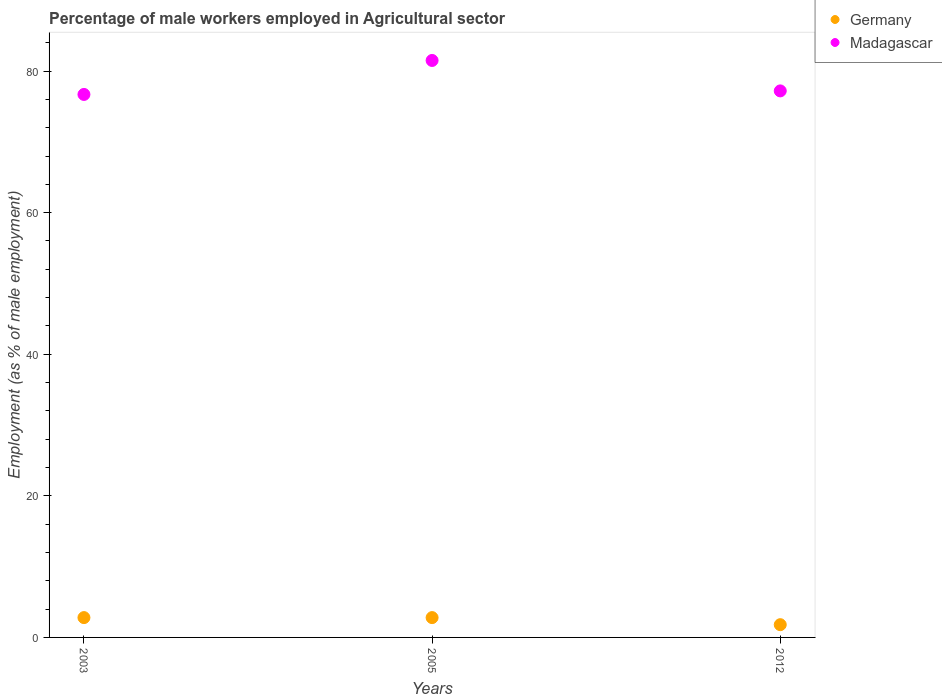How many different coloured dotlines are there?
Offer a terse response. 2. What is the percentage of male workers employed in Agricultural sector in Germany in 2005?
Offer a terse response. 2.8. Across all years, what is the maximum percentage of male workers employed in Agricultural sector in Madagascar?
Ensure brevity in your answer.  81.5. Across all years, what is the minimum percentage of male workers employed in Agricultural sector in Germany?
Offer a very short reply. 1.8. In which year was the percentage of male workers employed in Agricultural sector in Madagascar minimum?
Provide a short and direct response. 2003. What is the total percentage of male workers employed in Agricultural sector in Germany in the graph?
Provide a short and direct response. 7.4. What is the difference between the percentage of male workers employed in Agricultural sector in Germany in 2005 and that in 2012?
Ensure brevity in your answer.  1. What is the difference between the percentage of male workers employed in Agricultural sector in Germany in 2003 and the percentage of male workers employed in Agricultural sector in Madagascar in 2005?
Provide a succinct answer. -78.7. What is the average percentage of male workers employed in Agricultural sector in Germany per year?
Keep it short and to the point. 2.47. In the year 2003, what is the difference between the percentage of male workers employed in Agricultural sector in Germany and percentage of male workers employed in Agricultural sector in Madagascar?
Provide a short and direct response. -73.9. In how many years, is the percentage of male workers employed in Agricultural sector in Germany greater than 48 %?
Keep it short and to the point. 0. What is the ratio of the percentage of male workers employed in Agricultural sector in Germany in 2003 to that in 2012?
Ensure brevity in your answer.  1.56. What is the difference between the highest and the lowest percentage of male workers employed in Agricultural sector in Germany?
Give a very brief answer. 1. Does the percentage of male workers employed in Agricultural sector in Germany monotonically increase over the years?
Keep it short and to the point. No. Is the percentage of male workers employed in Agricultural sector in Madagascar strictly greater than the percentage of male workers employed in Agricultural sector in Germany over the years?
Offer a terse response. Yes. How many years are there in the graph?
Your response must be concise. 3. Does the graph contain any zero values?
Provide a short and direct response. No. Does the graph contain grids?
Give a very brief answer. No. Where does the legend appear in the graph?
Provide a succinct answer. Top right. How many legend labels are there?
Your answer should be compact. 2. How are the legend labels stacked?
Keep it short and to the point. Vertical. What is the title of the graph?
Provide a succinct answer. Percentage of male workers employed in Agricultural sector. What is the label or title of the X-axis?
Your response must be concise. Years. What is the label or title of the Y-axis?
Ensure brevity in your answer.  Employment (as % of male employment). What is the Employment (as % of male employment) of Germany in 2003?
Your response must be concise. 2.8. What is the Employment (as % of male employment) in Madagascar in 2003?
Your answer should be compact. 76.7. What is the Employment (as % of male employment) in Germany in 2005?
Keep it short and to the point. 2.8. What is the Employment (as % of male employment) of Madagascar in 2005?
Ensure brevity in your answer.  81.5. What is the Employment (as % of male employment) of Germany in 2012?
Make the answer very short. 1.8. What is the Employment (as % of male employment) of Madagascar in 2012?
Ensure brevity in your answer.  77.2. Across all years, what is the maximum Employment (as % of male employment) of Germany?
Keep it short and to the point. 2.8. Across all years, what is the maximum Employment (as % of male employment) of Madagascar?
Your answer should be very brief. 81.5. Across all years, what is the minimum Employment (as % of male employment) in Germany?
Your response must be concise. 1.8. Across all years, what is the minimum Employment (as % of male employment) in Madagascar?
Provide a short and direct response. 76.7. What is the total Employment (as % of male employment) in Germany in the graph?
Offer a very short reply. 7.4. What is the total Employment (as % of male employment) in Madagascar in the graph?
Your answer should be very brief. 235.4. What is the difference between the Employment (as % of male employment) of Germany in 2005 and that in 2012?
Offer a terse response. 1. What is the difference between the Employment (as % of male employment) in Germany in 2003 and the Employment (as % of male employment) in Madagascar in 2005?
Make the answer very short. -78.7. What is the difference between the Employment (as % of male employment) of Germany in 2003 and the Employment (as % of male employment) of Madagascar in 2012?
Your answer should be very brief. -74.4. What is the difference between the Employment (as % of male employment) in Germany in 2005 and the Employment (as % of male employment) in Madagascar in 2012?
Give a very brief answer. -74.4. What is the average Employment (as % of male employment) in Germany per year?
Offer a very short reply. 2.47. What is the average Employment (as % of male employment) in Madagascar per year?
Your response must be concise. 78.47. In the year 2003, what is the difference between the Employment (as % of male employment) of Germany and Employment (as % of male employment) of Madagascar?
Offer a very short reply. -73.9. In the year 2005, what is the difference between the Employment (as % of male employment) of Germany and Employment (as % of male employment) of Madagascar?
Your answer should be compact. -78.7. In the year 2012, what is the difference between the Employment (as % of male employment) in Germany and Employment (as % of male employment) in Madagascar?
Ensure brevity in your answer.  -75.4. What is the ratio of the Employment (as % of male employment) of Germany in 2003 to that in 2005?
Offer a terse response. 1. What is the ratio of the Employment (as % of male employment) in Madagascar in 2003 to that in 2005?
Offer a very short reply. 0.94. What is the ratio of the Employment (as % of male employment) of Germany in 2003 to that in 2012?
Give a very brief answer. 1.56. What is the ratio of the Employment (as % of male employment) of Madagascar in 2003 to that in 2012?
Give a very brief answer. 0.99. What is the ratio of the Employment (as % of male employment) in Germany in 2005 to that in 2012?
Your response must be concise. 1.56. What is the ratio of the Employment (as % of male employment) in Madagascar in 2005 to that in 2012?
Give a very brief answer. 1.06. What is the difference between the highest and the second highest Employment (as % of male employment) of Germany?
Your answer should be very brief. 0. What is the difference between the highest and the second highest Employment (as % of male employment) in Madagascar?
Keep it short and to the point. 4.3. 